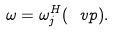Convert formula to latex. <formula><loc_0><loc_0><loc_500><loc_500>\omega = \omega _ { j } ^ { H } ( \ v p ) .</formula> 